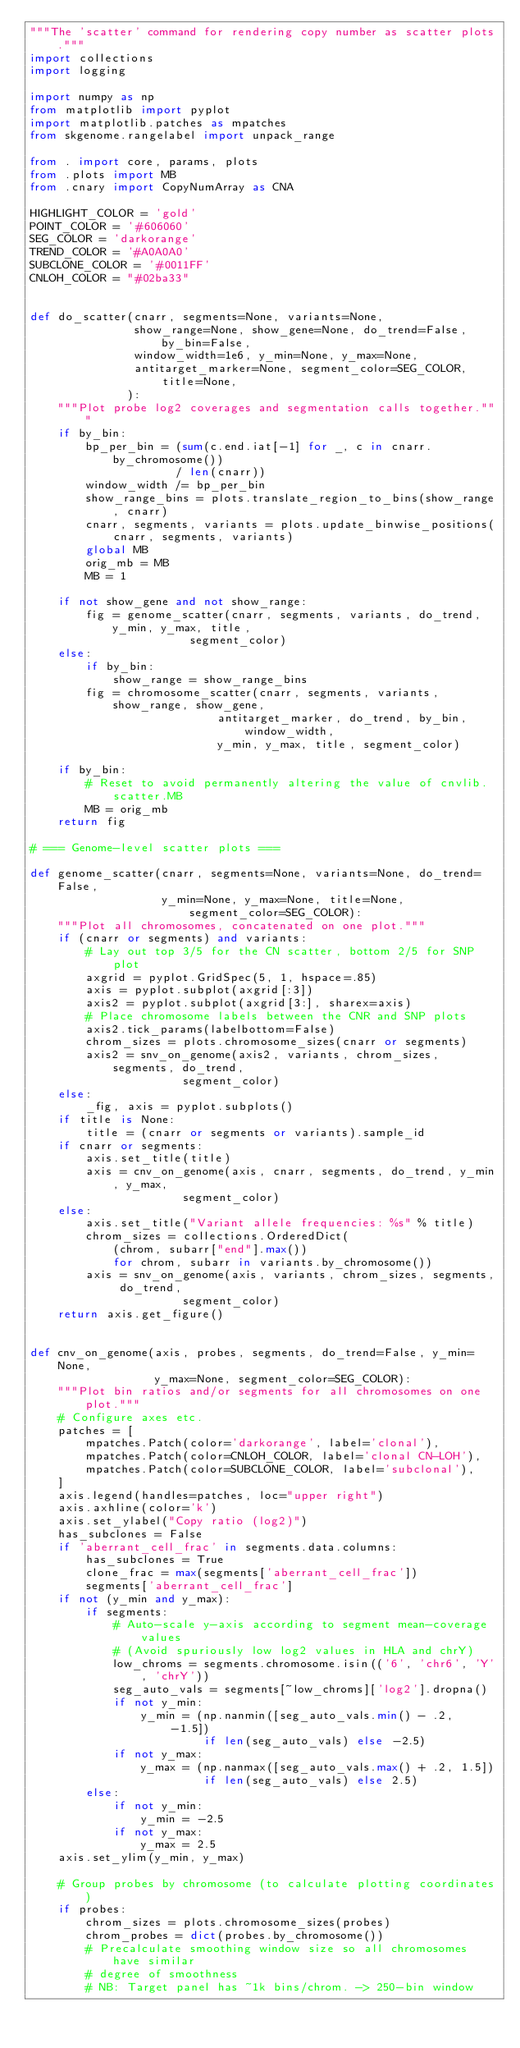<code> <loc_0><loc_0><loc_500><loc_500><_Python_>"""The 'scatter' command for rendering copy number as scatter plots."""
import collections
import logging

import numpy as np
from matplotlib import pyplot
import matplotlib.patches as mpatches
from skgenome.rangelabel import unpack_range

from . import core, params, plots
from .plots import MB
from .cnary import CopyNumArray as CNA

HIGHLIGHT_COLOR = 'gold'
POINT_COLOR = '#606060'
SEG_COLOR = 'darkorange'
TREND_COLOR = '#A0A0A0'
SUBCLONE_COLOR = '#0011FF'
CNLOH_COLOR = "#02ba33"


def do_scatter(cnarr, segments=None, variants=None,
               show_range=None, show_gene=None, do_trend=False, by_bin=False,
               window_width=1e6, y_min=None, y_max=None,
               antitarget_marker=None, segment_color=SEG_COLOR, title=None,
              ):
    """Plot probe log2 coverages and segmentation calls together."""
    if by_bin:
        bp_per_bin = (sum(c.end.iat[-1] for _, c in cnarr.by_chromosome())
                     / len(cnarr))
        window_width /= bp_per_bin
        show_range_bins = plots.translate_region_to_bins(show_range, cnarr)
        cnarr, segments, variants = plots.update_binwise_positions(
            cnarr, segments, variants)
        global MB
        orig_mb = MB
        MB = 1

    if not show_gene and not show_range:
        fig = genome_scatter(cnarr, segments, variants, do_trend, y_min, y_max, title,
                       segment_color)
    else:
        if by_bin:
            show_range = show_range_bins
        fig = chromosome_scatter(cnarr, segments, variants, show_range, show_gene,
                           antitarget_marker, do_trend, by_bin, window_width,
                           y_min, y_max, title, segment_color)

    if by_bin:
        # Reset to avoid permanently altering the value of cnvlib.scatter.MB
        MB = orig_mb
    return fig

# === Genome-level scatter plots ===

def genome_scatter(cnarr, segments=None, variants=None, do_trend=False,
                   y_min=None, y_max=None, title=None, segment_color=SEG_COLOR):
    """Plot all chromosomes, concatenated on one plot."""
    if (cnarr or segments) and variants:
        # Lay out top 3/5 for the CN scatter, bottom 2/5 for SNP plot
        axgrid = pyplot.GridSpec(5, 1, hspace=.85)
        axis = pyplot.subplot(axgrid[:3])
        axis2 = pyplot.subplot(axgrid[3:], sharex=axis)
        # Place chromosome labels between the CNR and SNP plots
        axis2.tick_params(labelbottom=False)
        chrom_sizes = plots.chromosome_sizes(cnarr or segments)
        axis2 = snv_on_genome(axis2, variants, chrom_sizes, segments, do_trend,
                      segment_color)
    else:
        _fig, axis = pyplot.subplots()
    if title is None:
        title = (cnarr or segments or variants).sample_id
    if cnarr or segments:
        axis.set_title(title)
        axis = cnv_on_genome(axis, cnarr, segments, do_trend, y_min, y_max,
                      segment_color)
    else:
        axis.set_title("Variant allele frequencies: %s" % title)
        chrom_sizes = collections.OrderedDict(
            (chrom, subarr["end"].max())
            for chrom, subarr in variants.by_chromosome())
        axis = snv_on_genome(axis, variants, chrom_sizes, segments, do_trend,
                      segment_color)
    return axis.get_figure()


def cnv_on_genome(axis, probes, segments, do_trend=False, y_min=None,
                  y_max=None, segment_color=SEG_COLOR):
    """Plot bin ratios and/or segments for all chromosomes on one plot."""
    # Configure axes etc.
    patches = [
        mpatches.Patch(color='darkorange', label='clonal'),
        mpatches.Patch(color=CNLOH_COLOR, label='clonal CN-LOH'),
        mpatches.Patch(color=SUBCLONE_COLOR, label='subclonal'),
    ]
    axis.legend(handles=patches, loc="upper right")
    axis.axhline(color='k')
    axis.set_ylabel("Copy ratio (log2)")
    has_subclones = False
    if 'aberrant_cell_frac' in segments.data.columns:
        has_subclones = True
        clone_frac = max(segments['aberrant_cell_frac'])
        segments['aberrant_cell_frac']
    if not (y_min and y_max):
        if segments:
            # Auto-scale y-axis according to segment mean-coverage values
            # (Avoid spuriously low log2 values in HLA and chrY)
            low_chroms = segments.chromosome.isin(('6', 'chr6', 'Y', 'chrY'))
            seg_auto_vals = segments[~low_chroms]['log2'].dropna()
            if not y_min:
                y_min = (np.nanmin([seg_auto_vals.min() - .2, -1.5])
                         if len(seg_auto_vals) else -2.5)
            if not y_max:
                y_max = (np.nanmax([seg_auto_vals.max() + .2, 1.5])
                         if len(seg_auto_vals) else 2.5)
        else:
            if not y_min:
                y_min = -2.5
            if not y_max:
                y_max = 2.5
    axis.set_ylim(y_min, y_max)

    # Group probes by chromosome (to calculate plotting coordinates)
    if probes:
        chrom_sizes = plots.chromosome_sizes(probes)
        chrom_probes = dict(probes.by_chromosome())
        # Precalculate smoothing window size so all chromosomes have similar
        # degree of smoothness
        # NB: Target panel has ~1k bins/chrom. -> 250-bin window</code> 